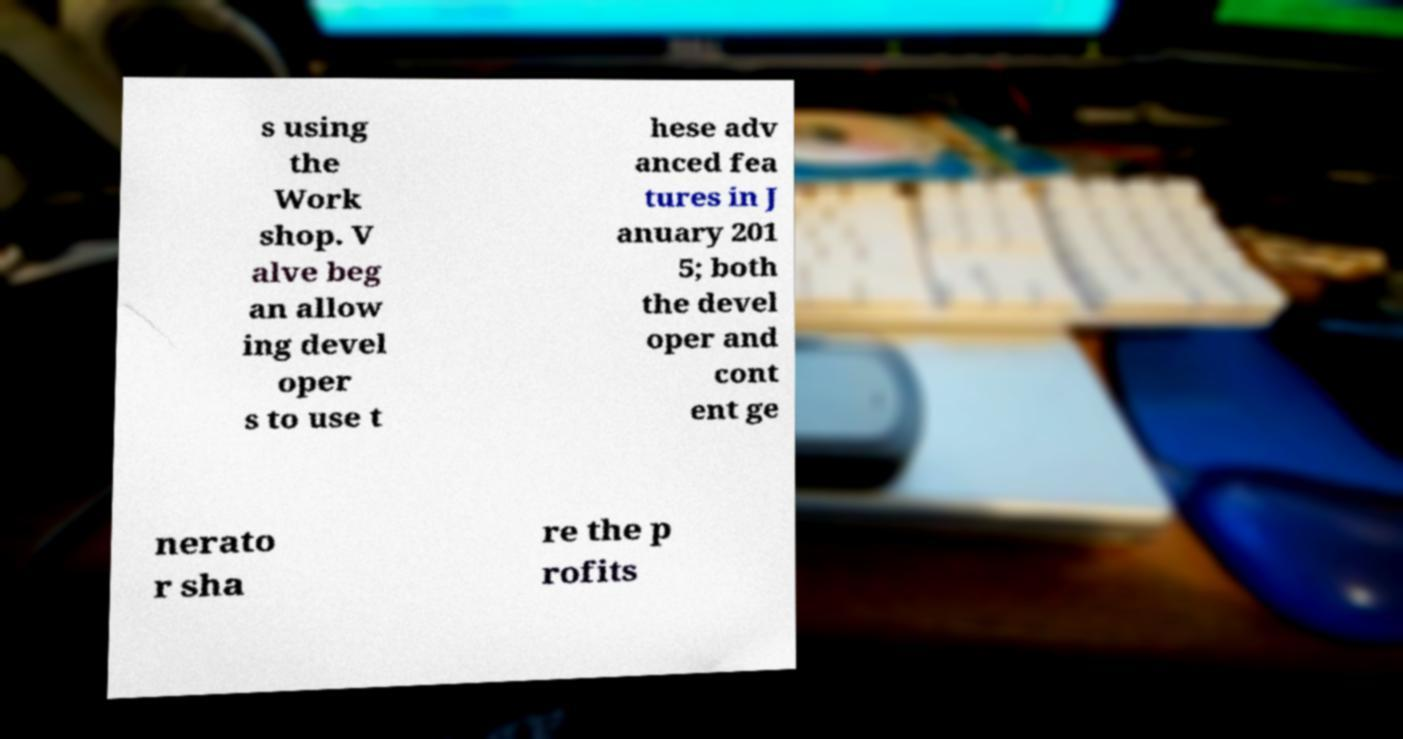Please identify and transcribe the text found in this image. s using the Work shop. V alve beg an allow ing devel oper s to use t hese adv anced fea tures in J anuary 201 5; both the devel oper and cont ent ge nerato r sha re the p rofits 